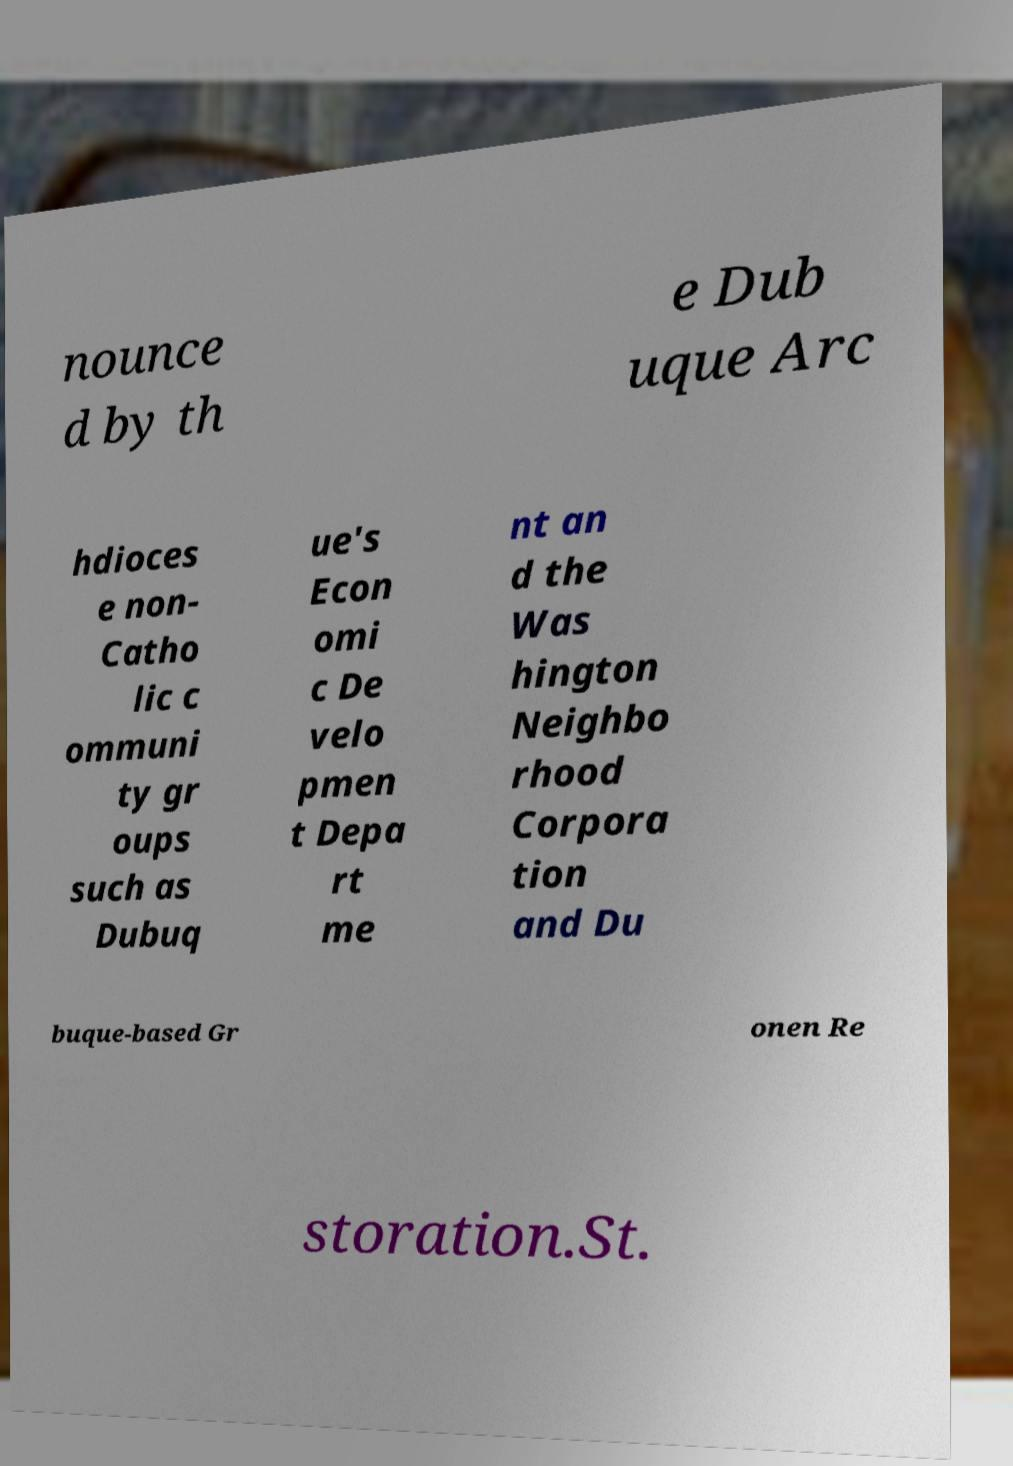Could you extract and type out the text from this image? nounce d by th e Dub uque Arc hdioces e non- Catho lic c ommuni ty gr oups such as Dubuq ue's Econ omi c De velo pmen t Depa rt me nt an d the Was hington Neighbo rhood Corpora tion and Du buque-based Gr onen Re storation.St. 